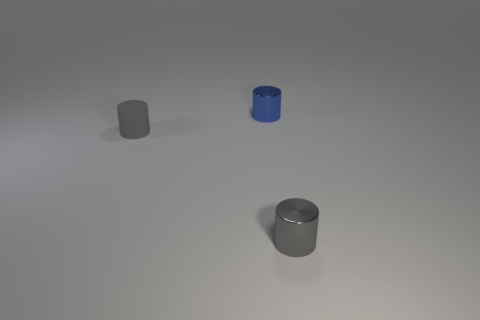Is there a small cylinder that has the same color as the tiny matte object?
Make the answer very short. Yes. Are any purple metallic cylinders visible?
Ensure brevity in your answer.  No. There is a small thing to the right of the blue metal cylinder; what is its color?
Make the answer very short. Gray. Do the matte cylinder and the blue metal cylinder that is to the right of the gray rubber cylinder have the same size?
Your response must be concise. Yes. There is a cylinder that is both to the left of the gray shiny object and right of the gray matte cylinder; how big is it?
Offer a terse response. Small. Are there any small gray cylinders made of the same material as the blue thing?
Provide a short and direct response. Yes. There is a tiny gray metallic object; what shape is it?
Make the answer very short. Cylinder. How many other things are there of the same shape as the rubber thing?
Your answer should be very brief. 2. There is a gray metallic object that is on the right side of the blue cylinder; what shape is it?
Keep it short and to the point. Cylinder. Is the number of tiny metallic cylinders behind the blue metal cylinder the same as the number of blue metallic cylinders?
Provide a short and direct response. No. 